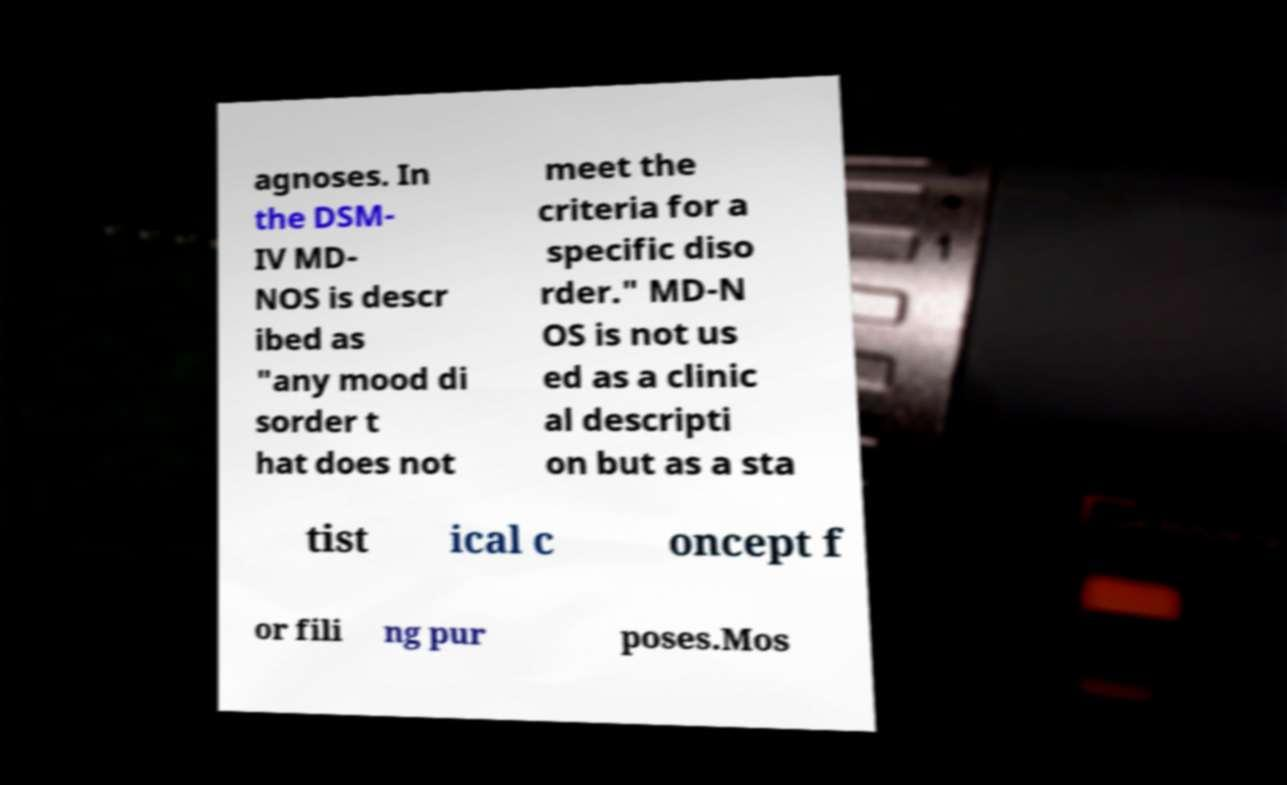I need the written content from this picture converted into text. Can you do that? agnoses. In the DSM- IV MD- NOS is descr ibed as "any mood di sorder t hat does not meet the criteria for a specific diso rder." MD-N OS is not us ed as a clinic al descripti on but as a sta tist ical c oncept f or fili ng pur poses.Mos 